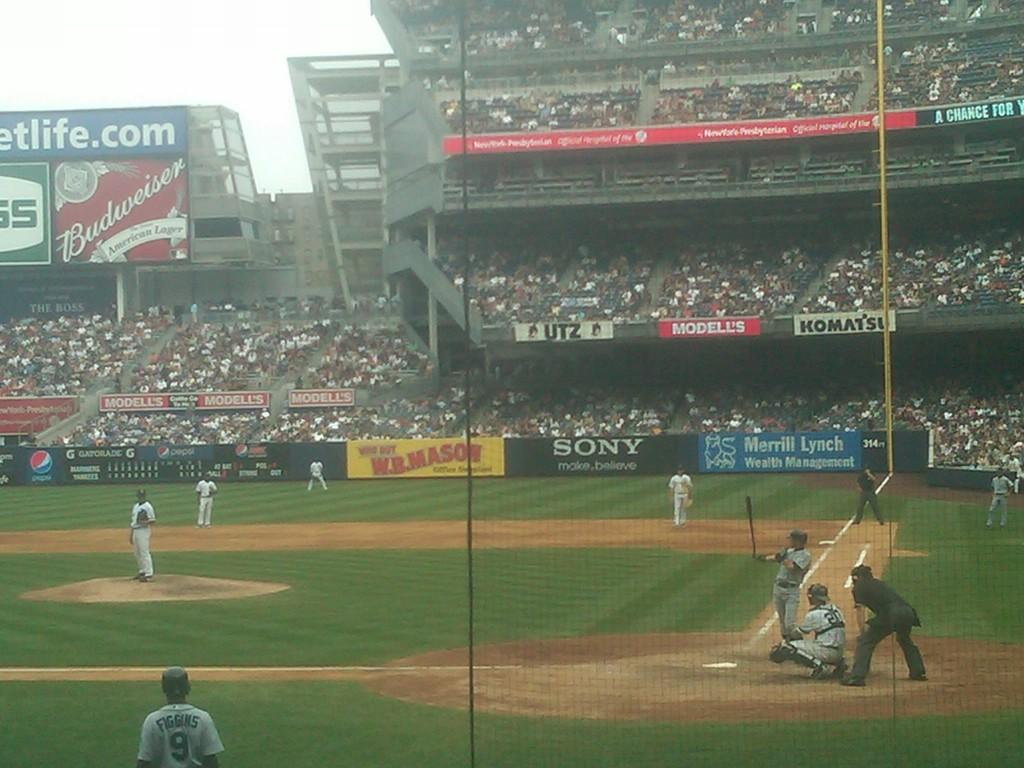<image>
Describe the image concisely. People play baseball in a field that shows advertisements for W.B. Mason, Sony, and Merrill Lynch. 